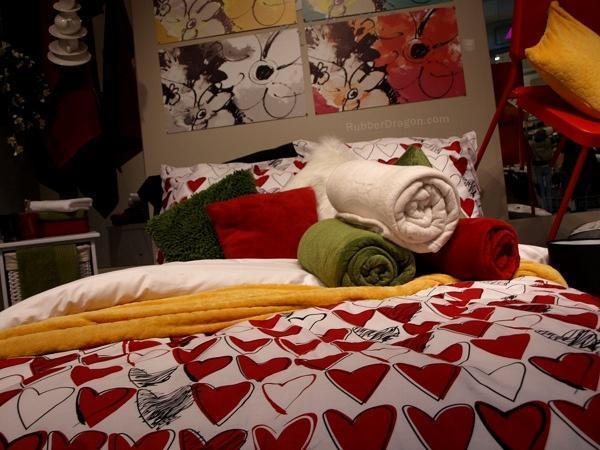How many blankets are rolled up on the bed?
Give a very brief answer. 3. 